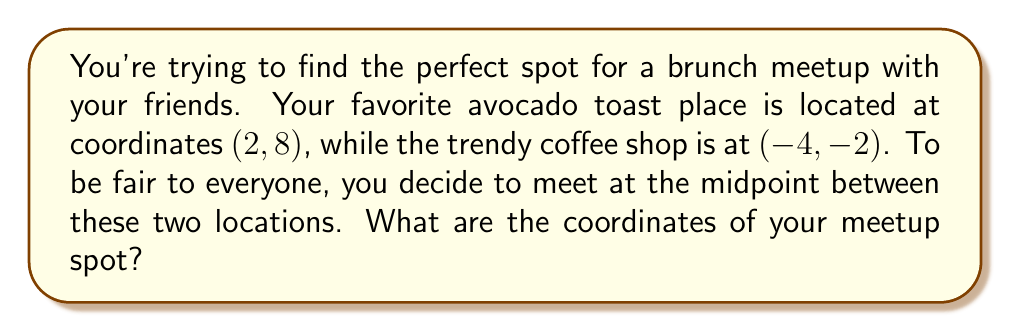Show me your answer to this math problem. Let's approach this step-by-step:

1) We have two points:
   Point A (avocado toast place): $(2, 8)$
   Point B (coffee shop): $(-4, -2)$

2) The midpoint formula is:
   $$\left(\frac{x_1 + x_2}{2}, \frac{y_1 + y_2}{2}\right)$$
   where $(x_1, y_1)$ is the first point and $(x_2, y_2)$ is the second point.

3) Let's substitute our values:
   $$\left(\frac{2 + (-4)}{2}, \frac{8 + (-2)}{2}\right)$$

4) Simplify inside the parentheses:
   $$\left(\frac{-2}{2}, \frac{6}{2}\right)$$

5) Perform the divisions:
   $(-1, 3)$

Therefore, the midpoint between your favorite avocado toast place and the trendy coffee shop is at coordinates $(-1, 3)$.

[asy]
unitsize(1cm);
defaultpen(fontsize(10pt));

// Draw the axes
draw((-5,0)--(5,0), arrow=Arrow(TeXHead));
draw((0,-3)--(0,9), arrow=Arrow(TeXHead));

// Label the axes
label("x", (5,0), E);
label("y", (0,9), N);

// Plot the points
dot((2,8), red);
dot((-4,-2), blue);
dot((-1,3), green);

// Label the points
label("(2,8)", (2,8), NE);
label("(-4,-2)", (-4,-2), SW);
label("(-1,3)", (-1,3), SE);

// Draw the line segment
draw((2,8)--(-4,-2), dashed);

// Add a legend
label("Avocado Toast", (3,-2), red);
label("Coffee Shop", (3,-2.5), blue);
label("Meetup Spot", (3,-3), green);
[/asy]
Answer: $(-1, 3)$ 